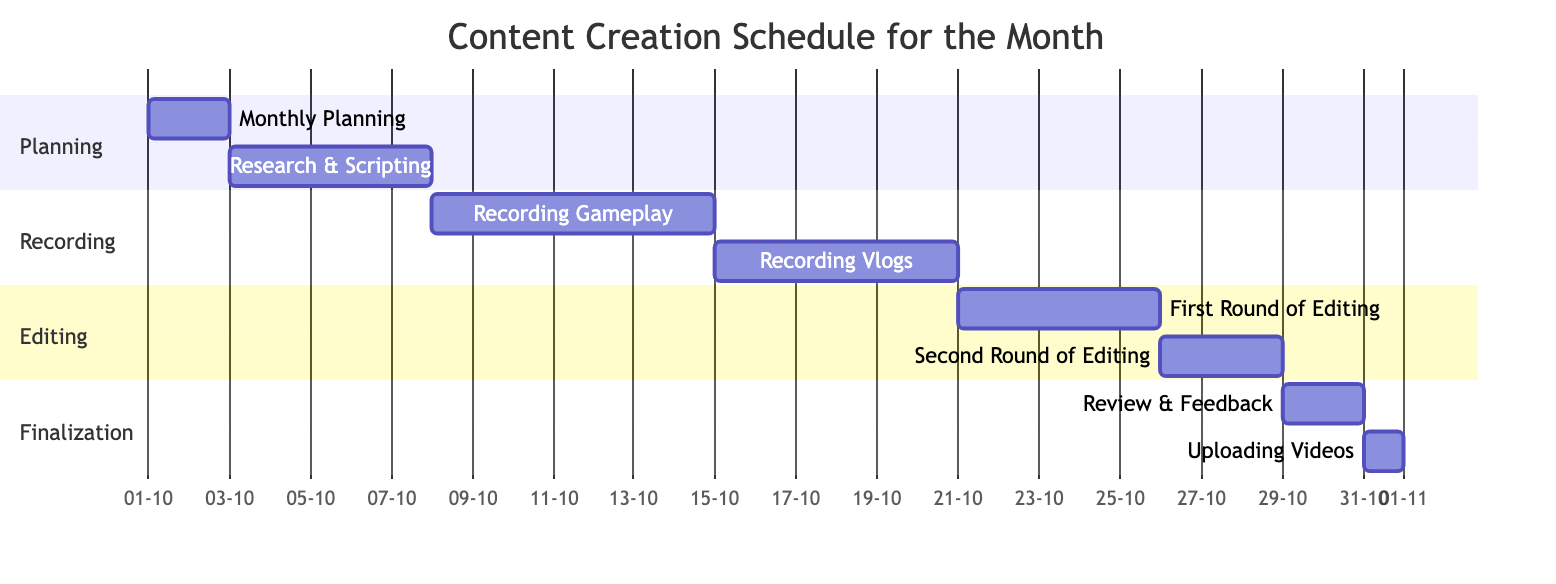What is the duration of the Monthly Planning task? The task "Monthly Planning" starts on October 1 and ends on October 2. Therefore, it lasts for 2 days.
Answer: 2 days How many tasks are scheduled in the Editing section? The Editing section contains two tasks: "First Round of Editing" and "Second Round of Editing." Therefore, the total count is 2 tasks.
Answer: 2 tasks What task follows Recording Vlogs? After "Recording Vlogs," which ends on October 20, the next task is "First Round of Editing," which begins on October 21.
Answer: First Round of Editing What is the total number of days planned for Research & Scripting? The "Research & Scripting" task starts on October 3 and ends on October 7, which is a total of 5 days.
Answer: 5 days Which task is scheduled to occur last in October? The final task in October is "Uploading Videos," which takes place on October 31.
Answer: Uploading Videos How many days are allocated for the Second Round of Editing? The "Second Round of Editing" task starts on October 26 and ends on October 28, which gives it a duration of 3 days.
Answer: 3 days What is the start date for the Recording Gameplay task? "Recording Gameplay" is scheduled to start on October 8, according to the timeline in the diagram.
Answer: October 8 What is the relationship between Monthly Planning and Research & Scripting? "Monthly Planning" must be completed before "Research & Scripting" starts, as the latter begins after the first task.
Answer: Sequential relationship How many total tasks are planned for the month? By counting each task listed in the schedule, there are a total of 8 tasks: Monthly Planning, Research & Scripting, Recording Gameplay, Recording Vlogs, First Round of Editing, Second Round of Editing, Review & Feedback, and Uploading Videos.
Answer: 8 tasks 